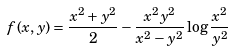<formula> <loc_0><loc_0><loc_500><loc_500>f ( x , y ) = \frac { x ^ { 2 } + y ^ { 2 } } { 2 } - \frac { x ^ { 2 } y ^ { 2 } } { x ^ { 2 } - y ^ { 2 } } \log \frac { x ^ { 2 } } { y ^ { 2 } }</formula> 